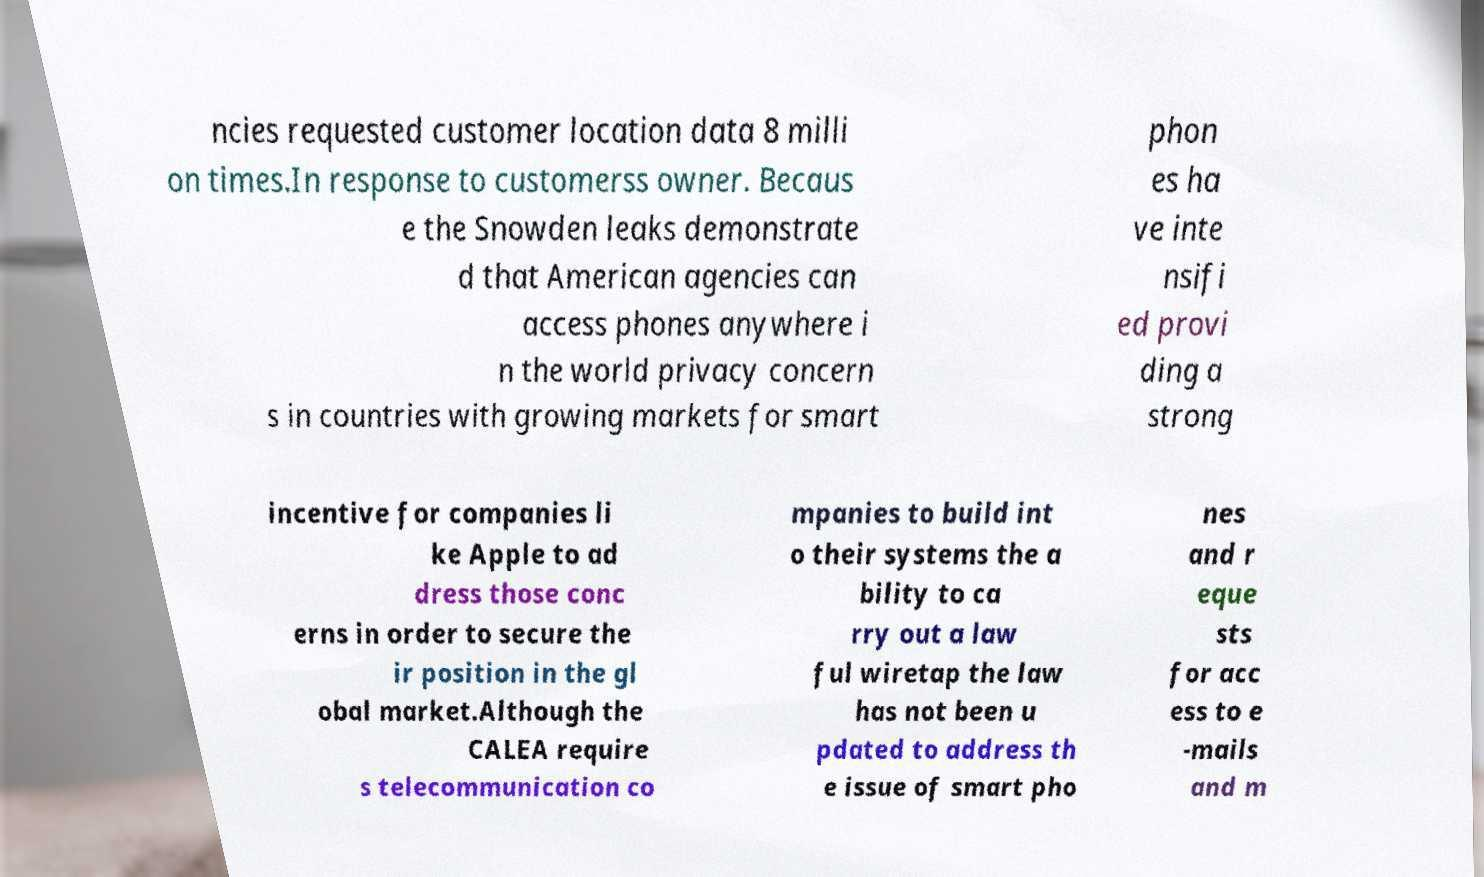Can you read and provide the text displayed in the image?This photo seems to have some interesting text. Can you extract and type it out for me? ncies requested customer location data 8 milli on times.In response to customerss owner. Becaus e the Snowden leaks demonstrate d that American agencies can access phones anywhere i n the world privacy concern s in countries with growing markets for smart phon es ha ve inte nsifi ed provi ding a strong incentive for companies li ke Apple to ad dress those conc erns in order to secure the ir position in the gl obal market.Although the CALEA require s telecommunication co mpanies to build int o their systems the a bility to ca rry out a law ful wiretap the law has not been u pdated to address th e issue of smart pho nes and r eque sts for acc ess to e -mails and m 